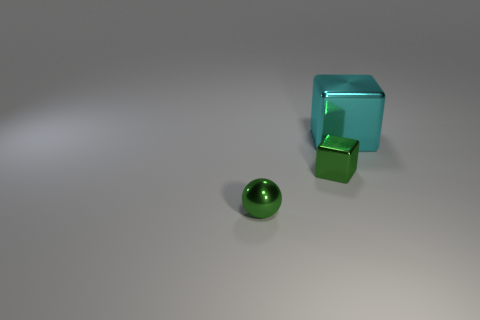Add 2 tiny red matte cylinders. How many objects exist? 5 Subtract all green blocks. How many blocks are left? 1 Subtract all spheres. How many objects are left? 2 Subtract all blue balls. How many cyan cubes are left? 1 Subtract all big purple spheres. Subtract all small shiny objects. How many objects are left? 1 Add 3 large metal things. How many large metal things are left? 4 Add 3 blocks. How many blocks exist? 5 Subtract 1 green spheres. How many objects are left? 2 Subtract 1 spheres. How many spheres are left? 0 Subtract all green blocks. Subtract all green cylinders. How many blocks are left? 1 